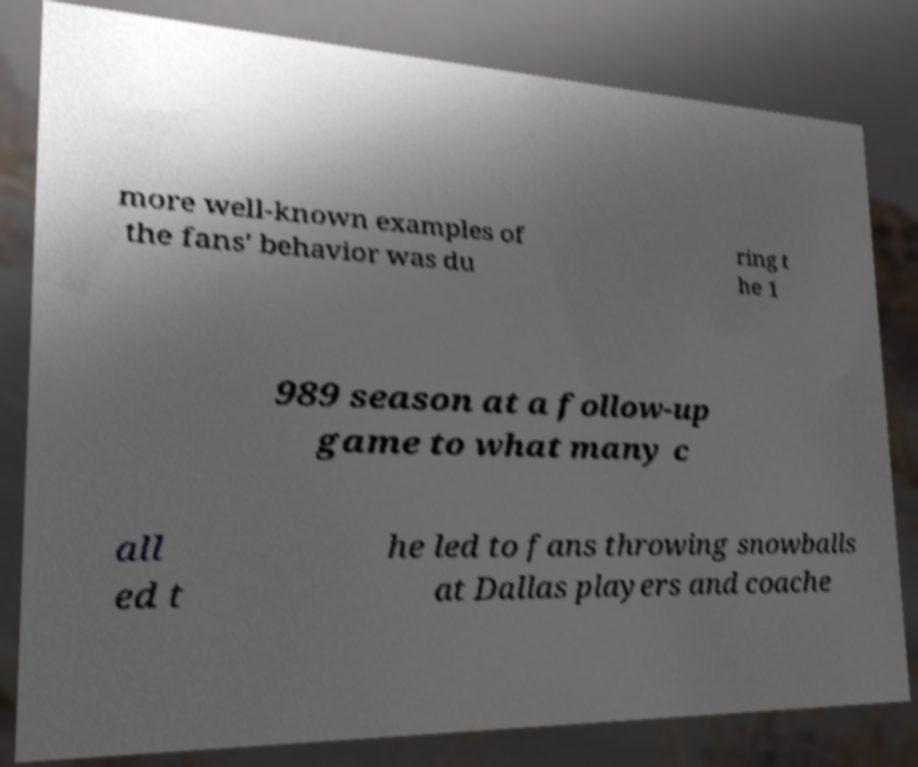Can you accurately transcribe the text from the provided image for me? more well-known examples of the fans' behavior was du ring t he 1 989 season at a follow-up game to what many c all ed t he led to fans throwing snowballs at Dallas players and coache 